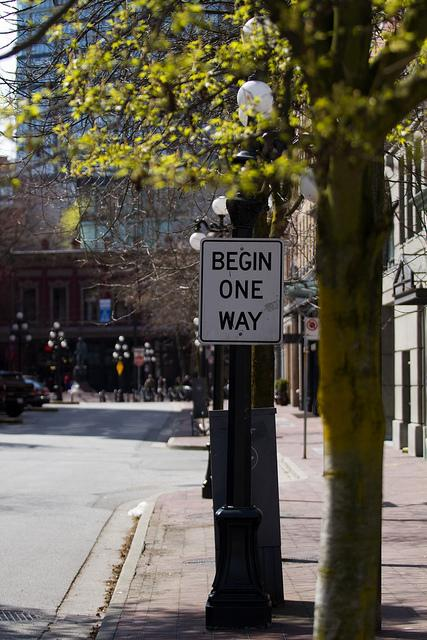What type of road is behind the person who took this picture?

Choices:
A) two way
B) one way
C) on ramp
D) none two way 